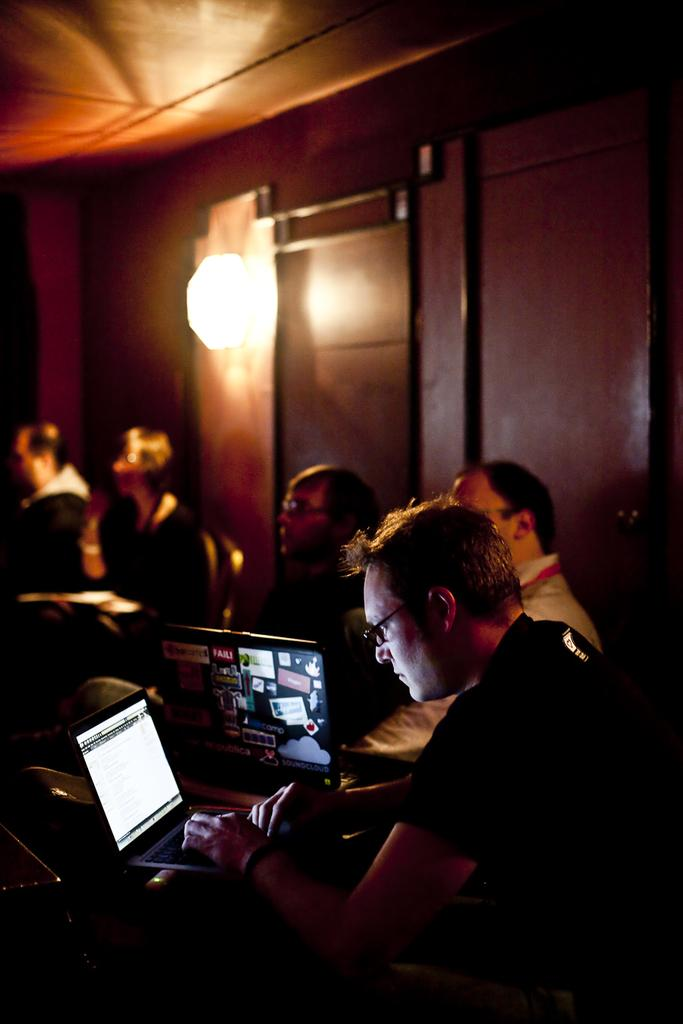What is the man in the image doing? The man in the image is working on a laptop. Can you describe the group of people in the image? There is a group of people sitting in the image. What can be seen providing illumination in the image? There is a light in the image. What is the background of the image made of? There is a wall in the image. What type of sheet is being used to put out the fire in the image? There is no fire present in the image, so there is no need for a sheet to put it out. 